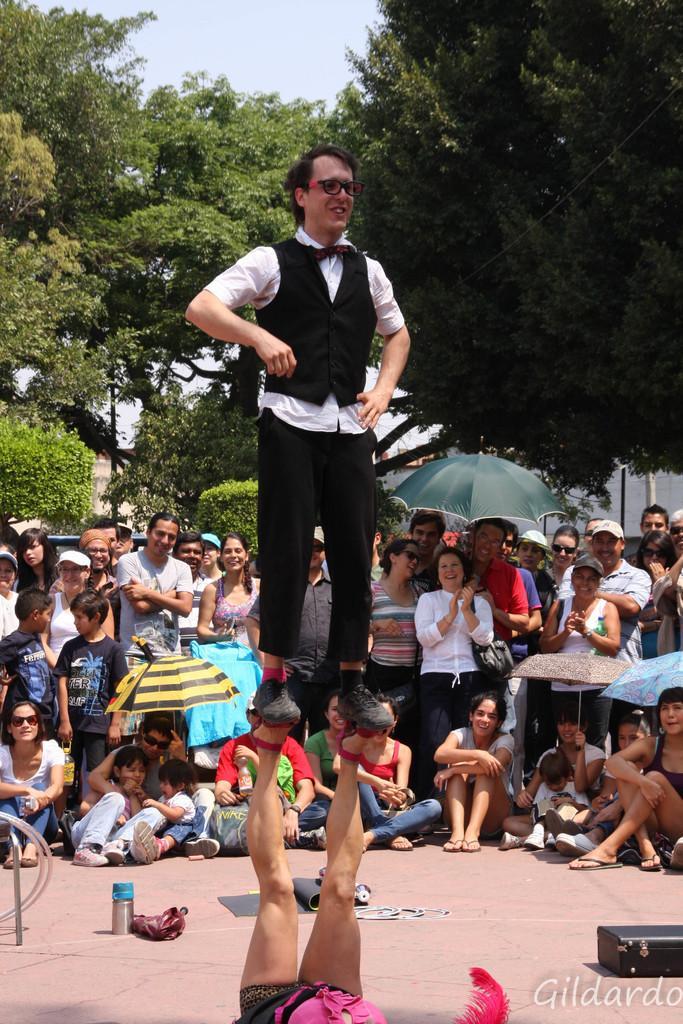In one or two sentences, can you explain what this image depicts? In this image there are many people. In the foreground there is a person lying and lifting his legs. There is another person standing on those legs. Behind them there are people standing and a few people sitting on the floor. In the background there are trees. At the top there is the sky. In the bottom right there is text on the image. There are mats, a box and a bottle on the ground. 